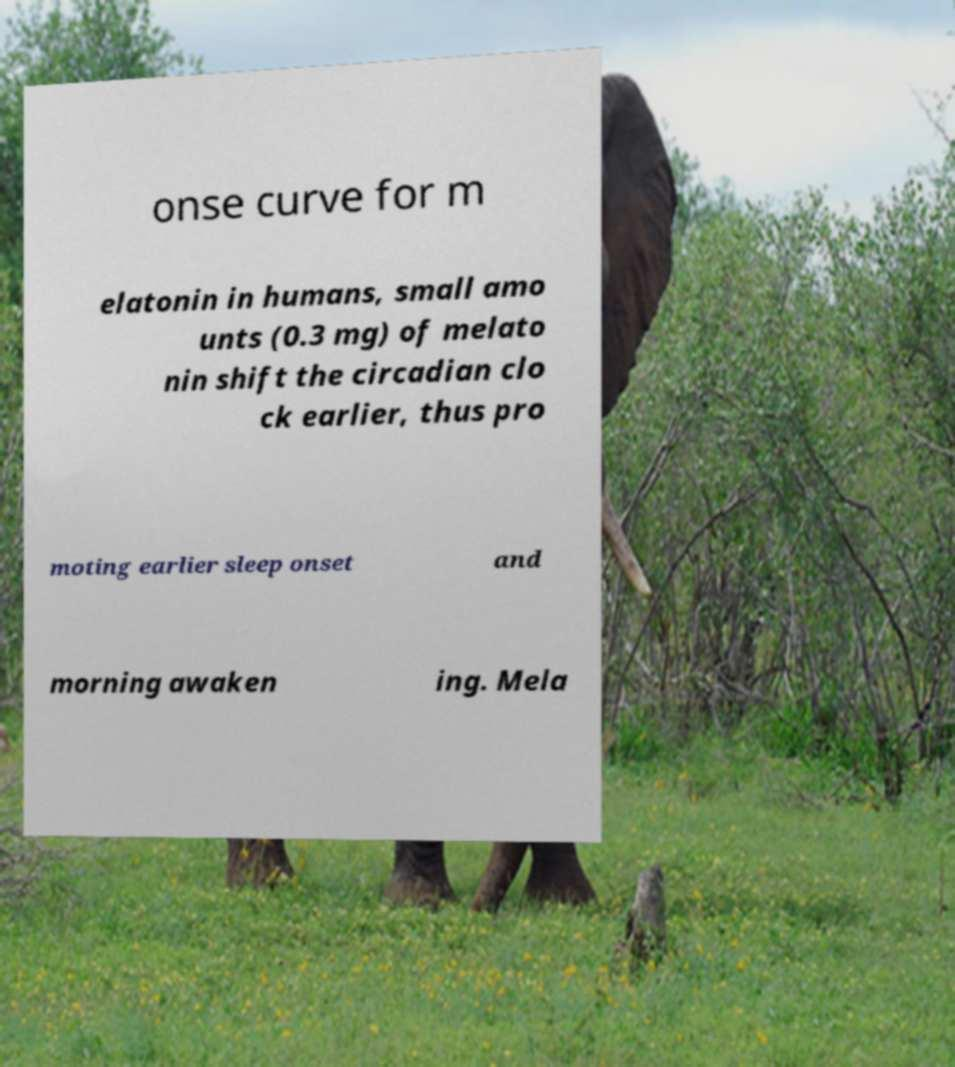What messages or text are displayed in this image? I need them in a readable, typed format. onse curve for m elatonin in humans, small amo unts (0.3 mg) of melato nin shift the circadian clo ck earlier, thus pro moting earlier sleep onset and morning awaken ing. Mela 